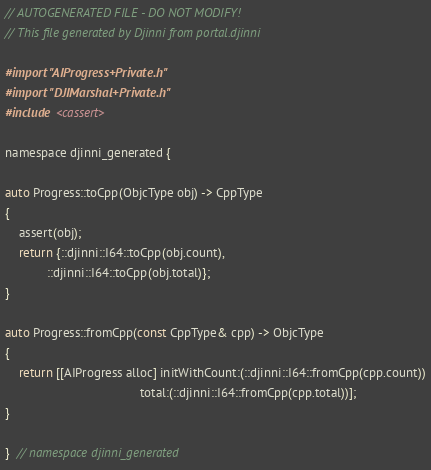Convert code to text. <code><loc_0><loc_0><loc_500><loc_500><_ObjectiveC_>// AUTOGENERATED FILE - DO NOT MODIFY!
// This file generated by Djinni from portal.djinni

#import "AIProgress+Private.h"
#import "DJIMarshal+Private.h"
#include <cassert>

namespace djinni_generated {

auto Progress::toCpp(ObjcType obj) -> CppType
{
    assert(obj);
    return {::djinni::I64::toCpp(obj.count),
            ::djinni::I64::toCpp(obj.total)};
}

auto Progress::fromCpp(const CppType& cpp) -> ObjcType
{
    return [[AIProgress alloc] initWithCount:(::djinni::I64::fromCpp(cpp.count))
                                       total:(::djinni::I64::fromCpp(cpp.total))];
}

}  // namespace djinni_generated
</code> 